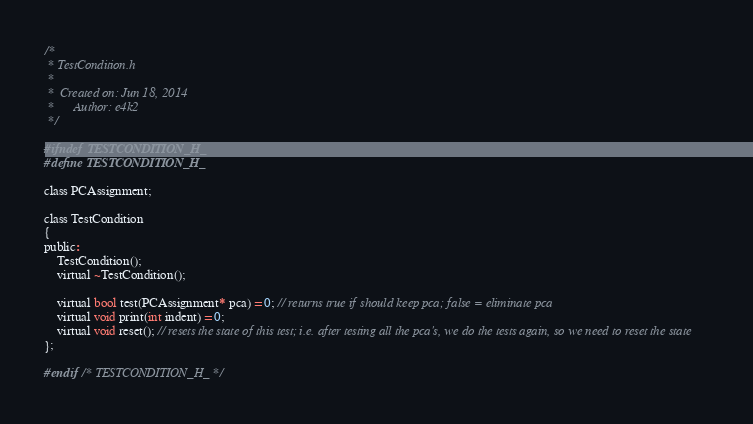<code> <loc_0><loc_0><loc_500><loc_500><_C_>/*
 * TestCondition.h
 *
 *  Created on: Jun 18, 2014
 *      Author: e4k2
 */

#ifndef TESTCONDITION_H_
#define TESTCONDITION_H_

class PCAssignment;

class TestCondition
{
public:
	TestCondition();
	virtual ~TestCondition();

	virtual bool test(PCAssignment* pca) = 0; // returns true if should keep pca; false = eliminate pca
	virtual void print(int indent) = 0;
	virtual void reset(); // resets the state of this test; i.e. after testing all the pca's, we do the tests again, so we need to reset the state
};

#endif /* TESTCONDITION_H_ */
</code> 